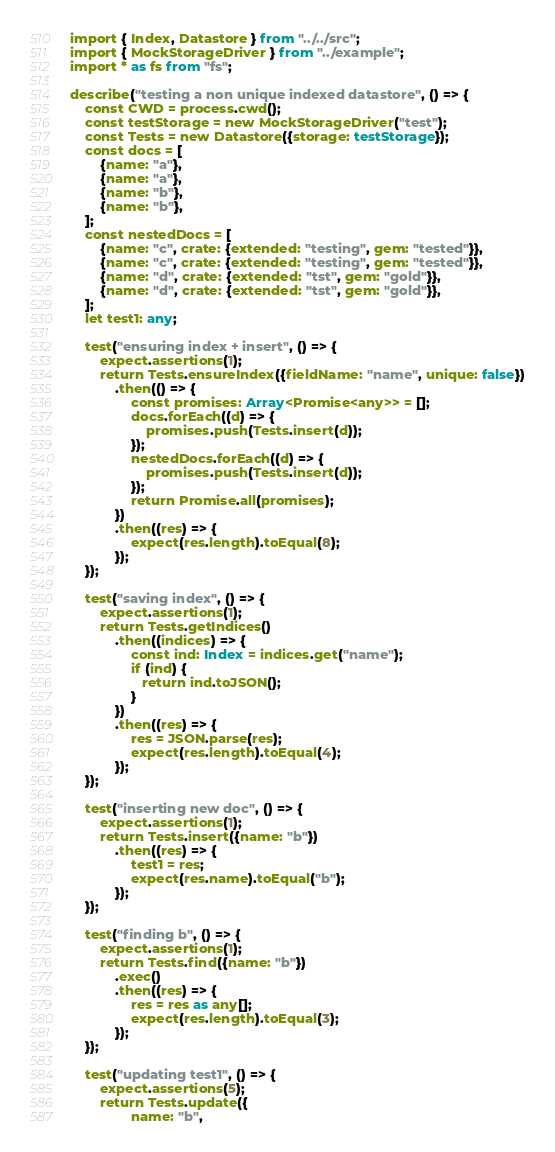<code> <loc_0><loc_0><loc_500><loc_500><_TypeScript_>import { Index, Datastore } from "../../src";
import { MockStorageDriver } from "../example";
import * as fs from "fs";

describe("testing a non unique indexed datastore", () => {
    const CWD = process.cwd();
    const testStorage = new MockStorageDriver("test");
    const Tests = new Datastore({storage: testStorage});
    const docs = [
        {name: "a"},
        {name: "a"},
        {name: "b"},
        {name: "b"},
    ];
    const nestedDocs = [
        {name: "c", crate: {extended: "testing", gem: "tested"}},
        {name: "c", crate: {extended: "testing", gem: "tested"}},
        {name: "d", crate: {extended: "tst", gem: "gold"}},
        {name: "d", crate: {extended: "tst", gem: "gold"}},
    ];
    let test1: any;

    test("ensuring index + insert", () => {
        expect.assertions(1);
        return Tests.ensureIndex({fieldName: "name", unique: false})
            .then(() => {
                const promises: Array<Promise<any>> = [];
                docs.forEach((d) => {
                    promises.push(Tests.insert(d));
                });
                nestedDocs.forEach((d) => {
                    promises.push(Tests.insert(d));
                });
                return Promise.all(promises);
            })
            .then((res) => {
                expect(res.length).toEqual(8);
            });
    });

    test("saving index", () => {
        expect.assertions(1);
        return Tests.getIndices()
            .then((indices) => {
                const ind: Index = indices.get("name");
                if (ind) {
                   return ind.toJSON();
                }
            })
            .then((res) => {
                res = JSON.parse(res);
                expect(res.length).toEqual(4);
            });
    });

    test("inserting new doc", () => {
        expect.assertions(1);
        return Tests.insert({name: "b"})
            .then((res) => {
                test1 = res;
                expect(res.name).toEqual("b");
            });
    });

    test("finding b", () => {
        expect.assertions(1);
        return Tests.find({name: "b"})
            .exec()
            .then((res) => {
                res = res as any[];
                expect(res.length).toEqual(3);
            });
    });

    test("updating test1", () => {
        expect.assertions(5);
        return Tests.update({
                name: "b",</code> 